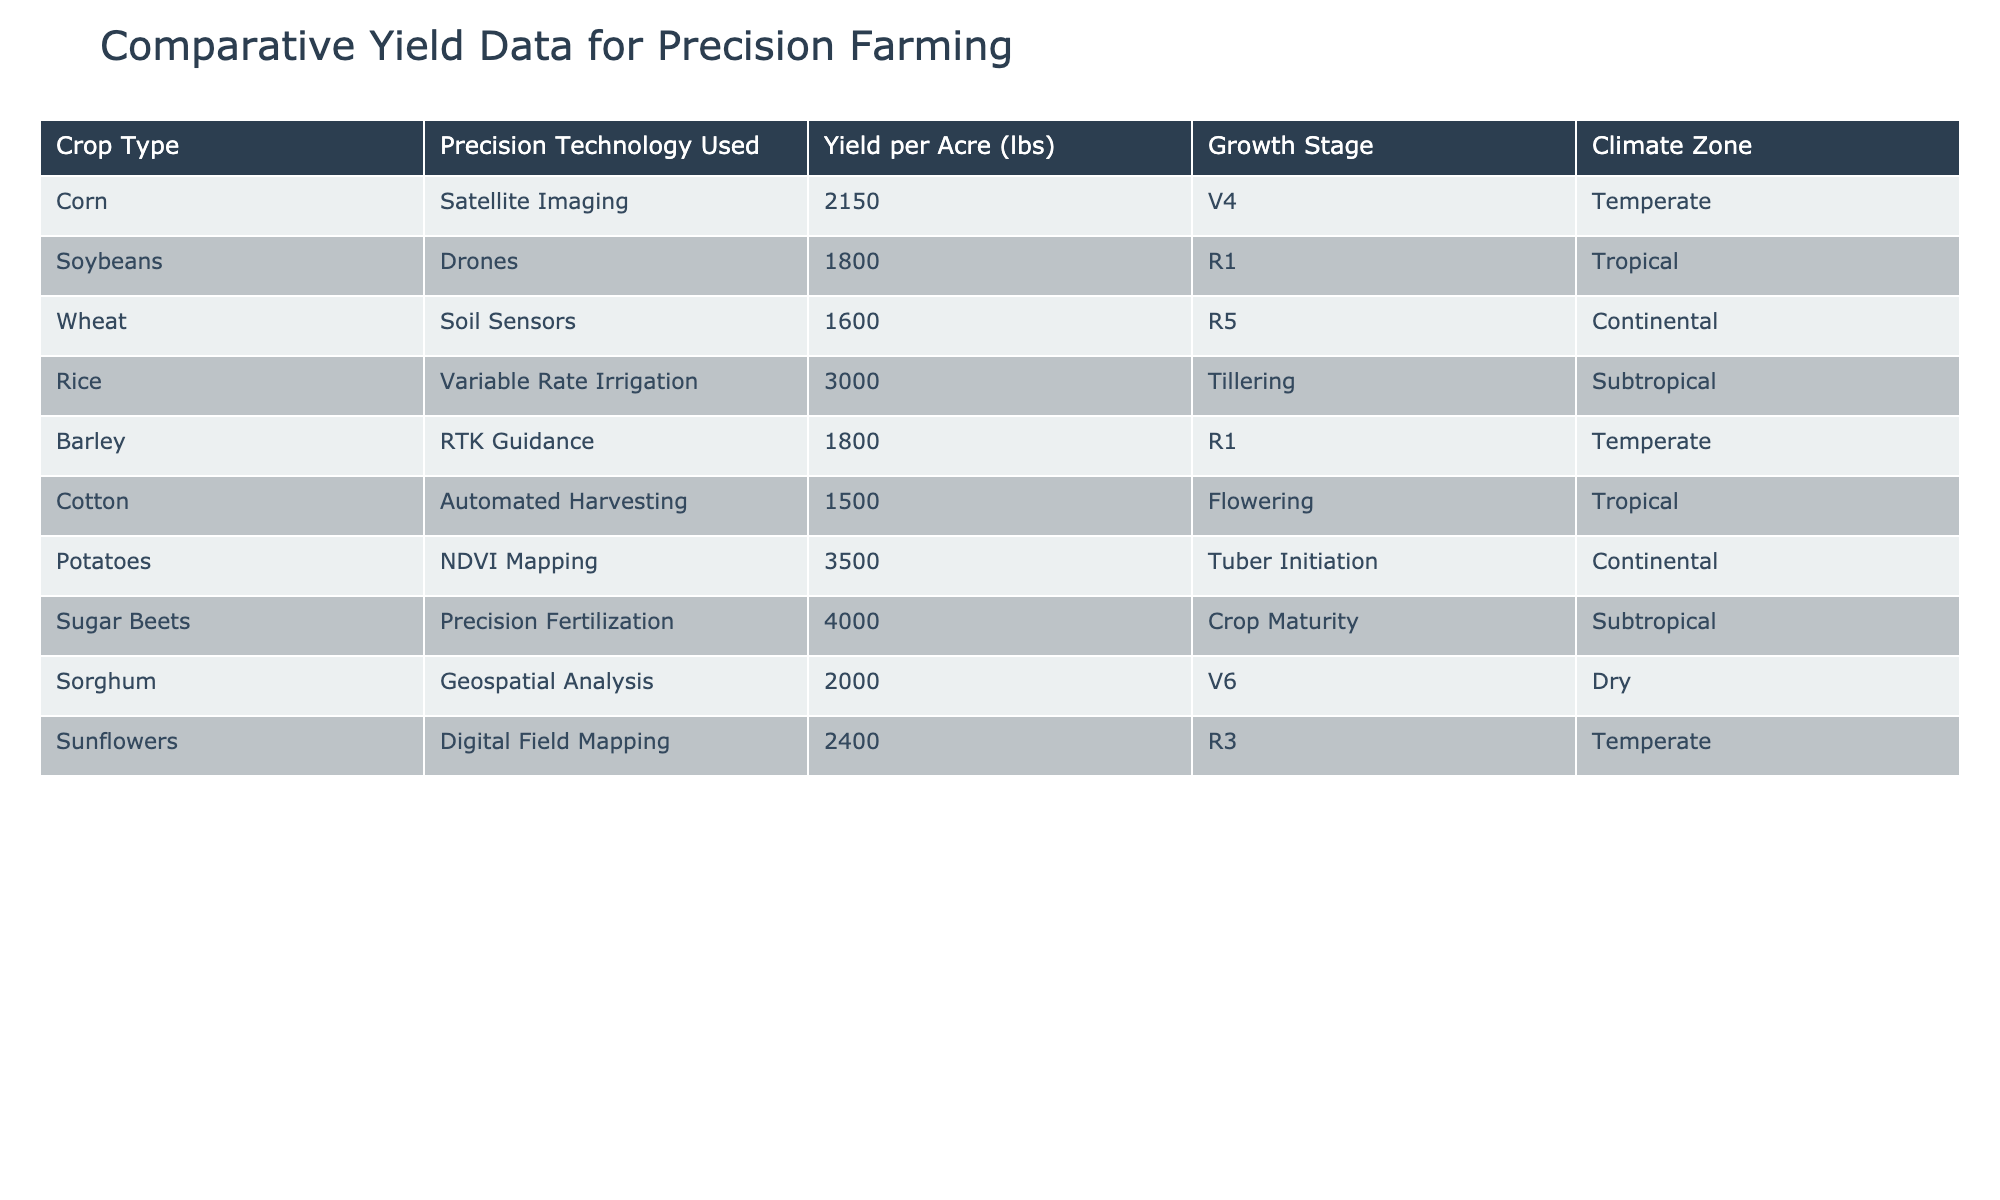What is the yield per acre for sugar beets? The table indicates the yield per acre for sugar beets, which can be found in the corresponding row under "Yield per Acre (lbs)". The value listed is 4000 lbs per acre.
Answer: 4000 lbs Which crop has the highest yield per acre? By comparing the yield per acre for all crops listed in the table, sugar beets have the highest yield at 4000 lbs per acre.
Answer: Sugar beets Is the yield for cotton higher than that for soybeans? The yield for cotton is 1500 lbs per acre, while the yield for soybeans is 1800 lbs per acre. Since 1500 is less than 1800, the statement is false.
Answer: No What is the average yield per acre for crops using tropical climate zones? The crops in the tropical climate zone are soybeans with a yield of 1800 lbs and cotton with a yield of 1500 lbs. To find the average, sum these two yields (1800 + 1500 = 3300 lbs) and divide by 2 (3300 / 2 = 1650 lbs).
Answer: 1650 lbs Which crop type in the temperate climate zone has the highest yield? In the temperate climate zone, the crops listed are corn (2150 lbs), barley (1800 lbs), and sunflowers (2400 lbs). Among these, sunflowers have the highest yield at 2400 lbs per acre.
Answer: Sunflowers 